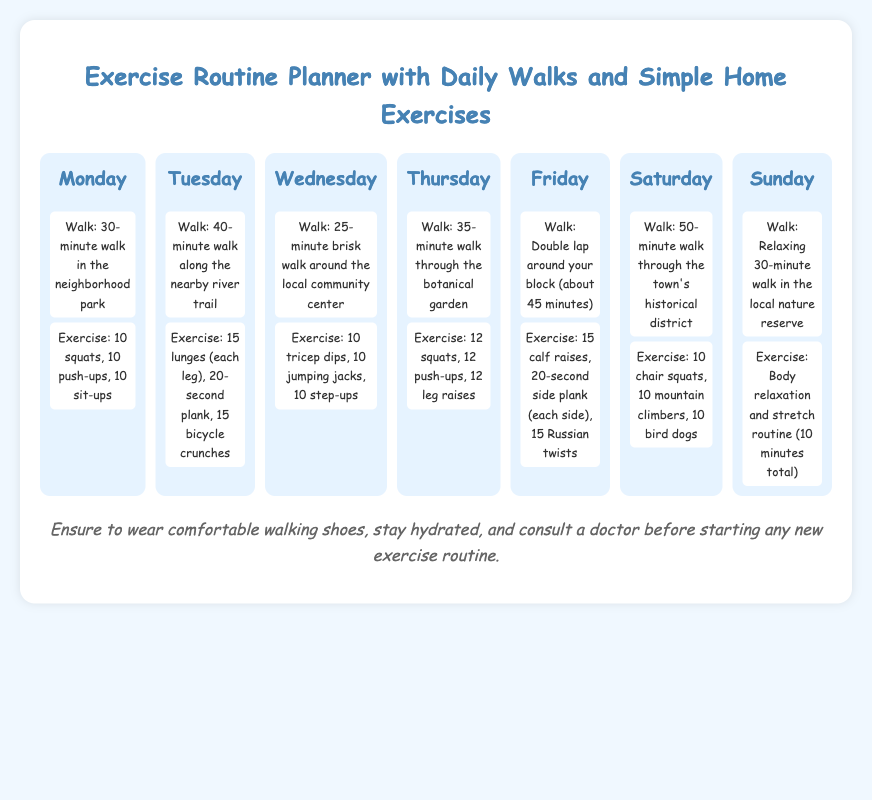What activity is scheduled for Monday? The activity scheduled for Monday includes a 30-minute walk in the neighborhood park and simple exercises.
Answer: Walk: 30-minute walk in the neighborhood park How long is the walk on Tuesday? The walk on Tuesday is a 40-minute walk along the nearby river trail.
Answer: 40-minute What exercises are included on Friday? The exercises listed for Friday include calf raises, side plank, and Russian twists.
Answer: 15 calf raises, 20-second side plank (each side), 15 Russian twists Which day has the longest walk? Saturday has the longest walk scheduled through the town's historical district for 50 minutes.
Answer: 50-minute What is the total number of squats on Thursday? On Thursday, the routine includes 12 squats as part of the exercises.
Answer: 12 squats What type of routine is scheduled for Sunday? Sunday has a body relaxation and stretch routine.
Answer: Body relaxation and stretch routine How many push-ups are listed for Monday? Monday includes 10 push-ups as part of the exercise routine.
Answer: 10 push-ups What should you ensure regarding your shoes? It's suggested to wear comfortable walking shoes.
Answer: Comfortable walking shoes 